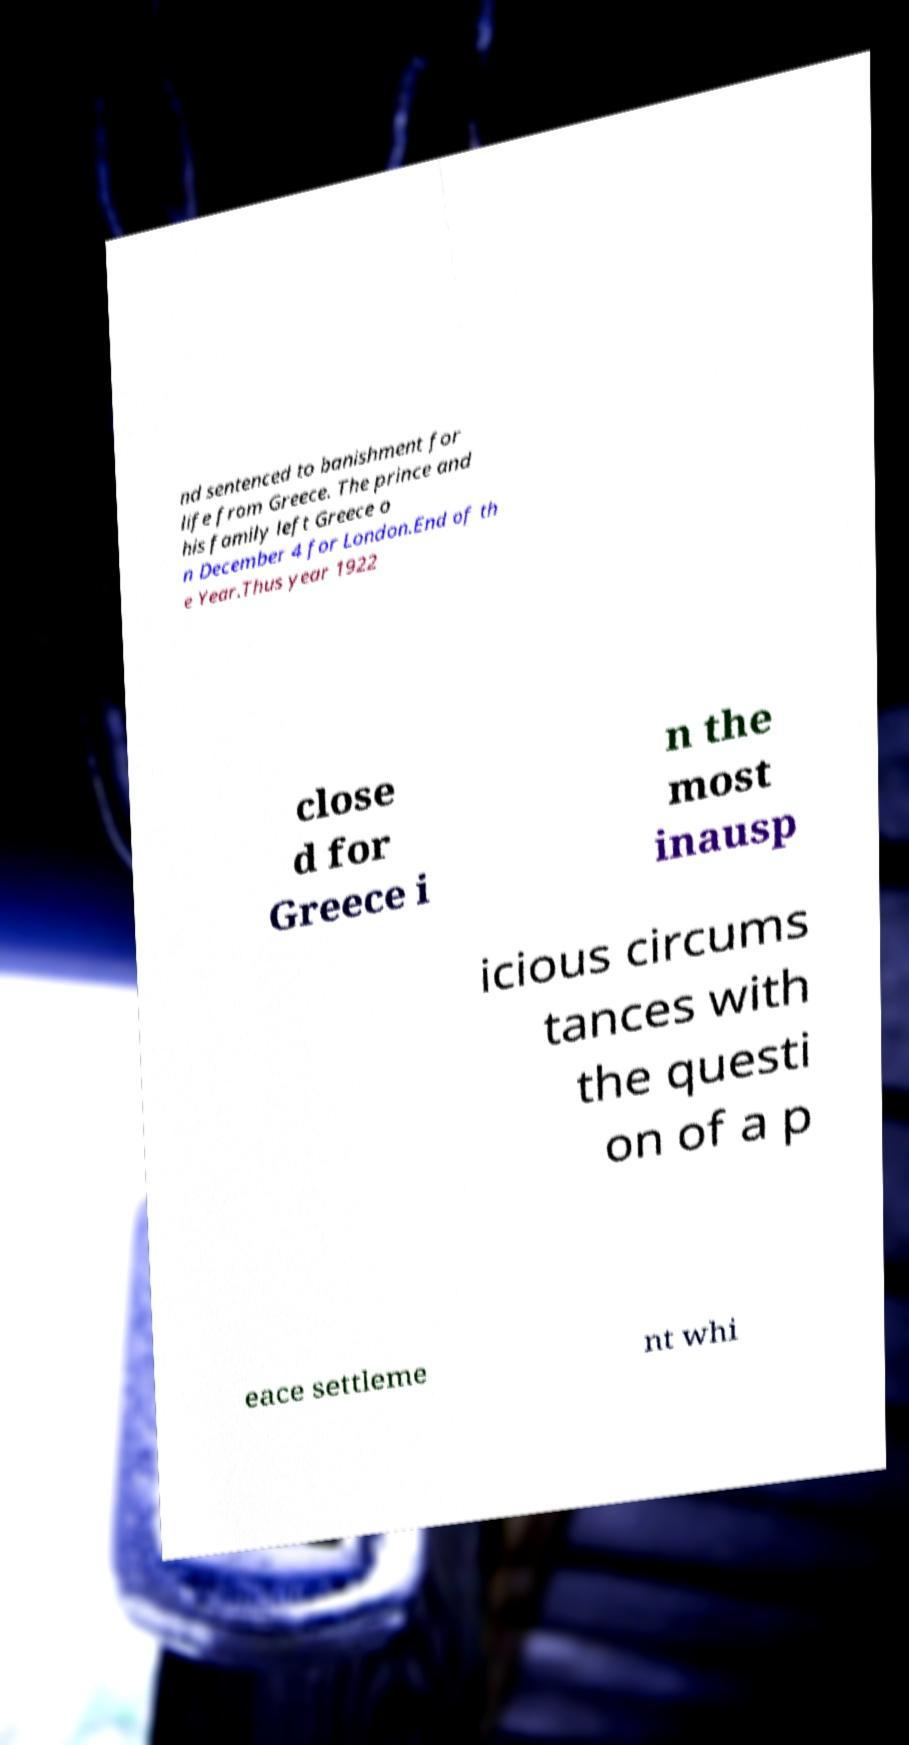Could you assist in decoding the text presented in this image and type it out clearly? nd sentenced to banishment for life from Greece. The prince and his family left Greece o n December 4 for London.End of th e Year.Thus year 1922 close d for Greece i n the most inausp icious circums tances with the questi on of a p eace settleme nt whi 